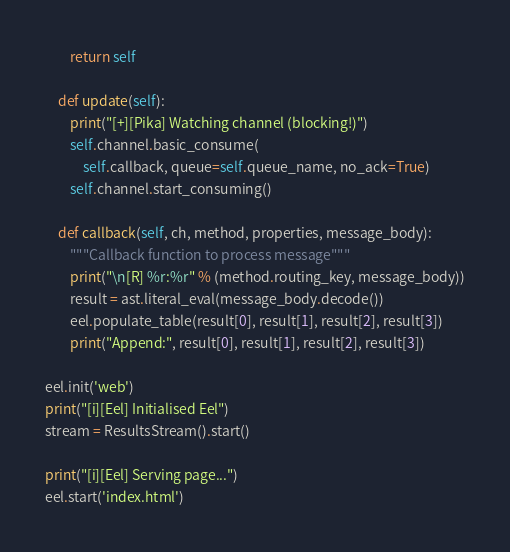<code> <loc_0><loc_0><loc_500><loc_500><_Python_>        return self

    def update(self):
        print("[+][Pika] Watching channel (blocking!)")
        self.channel.basic_consume(
            self.callback, queue=self.queue_name, no_ack=True)
        self.channel.start_consuming()

    def callback(self, ch, method, properties, message_body):
        """Callback function to process message"""
        print("\n[R] %r:%r" % (method.routing_key, message_body))
        result = ast.literal_eval(message_body.decode())
        eel.populate_table(result[0], result[1], result[2], result[3])
        print("Append:", result[0], result[1], result[2], result[3])

eel.init('web')
print("[i][Eel] Initialised Eel")
stream = ResultsStream().start()

print("[i][Eel] Serving page...")
eel.start('index.html')
</code> 